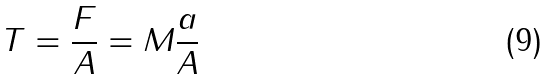<formula> <loc_0><loc_0><loc_500><loc_500>T = \frac { F } { A } = M \frac { a } { A }</formula> 